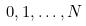Convert formula to latex. <formula><loc_0><loc_0><loc_500><loc_500>0 , 1 , \dots , N</formula> 